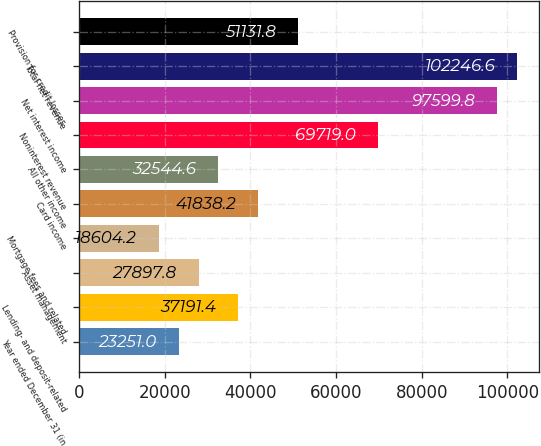Convert chart to OTSL. <chart><loc_0><loc_0><loc_500><loc_500><bar_chart><fcel>Year ended December 31 (in<fcel>Lending- and deposit-related<fcel>Asset management<fcel>Mortgage fees and related<fcel>Card income<fcel>All other income<fcel>Noninterest revenue<fcel>Net interest income<fcel>Total net revenue<fcel>Provision for credit losses<nl><fcel>23251<fcel>37191.4<fcel>27897.8<fcel>18604.2<fcel>41838.2<fcel>32544.6<fcel>69719<fcel>97599.8<fcel>102247<fcel>51131.8<nl></chart> 